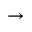<formula> <loc_0><loc_0><loc_500><loc_500>\rightarrow</formula> 